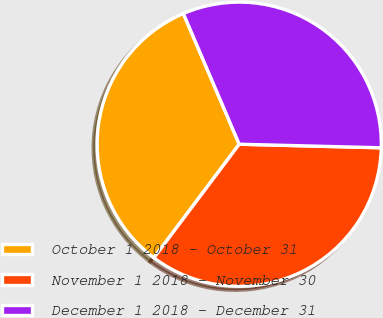Convert chart to OTSL. <chart><loc_0><loc_0><loc_500><loc_500><pie_chart><fcel>October 1 2018 - October 31<fcel>November 1 2018 - November 30<fcel>December 1 2018 - December 31<nl><fcel>33.32%<fcel>34.85%<fcel>31.83%<nl></chart> 